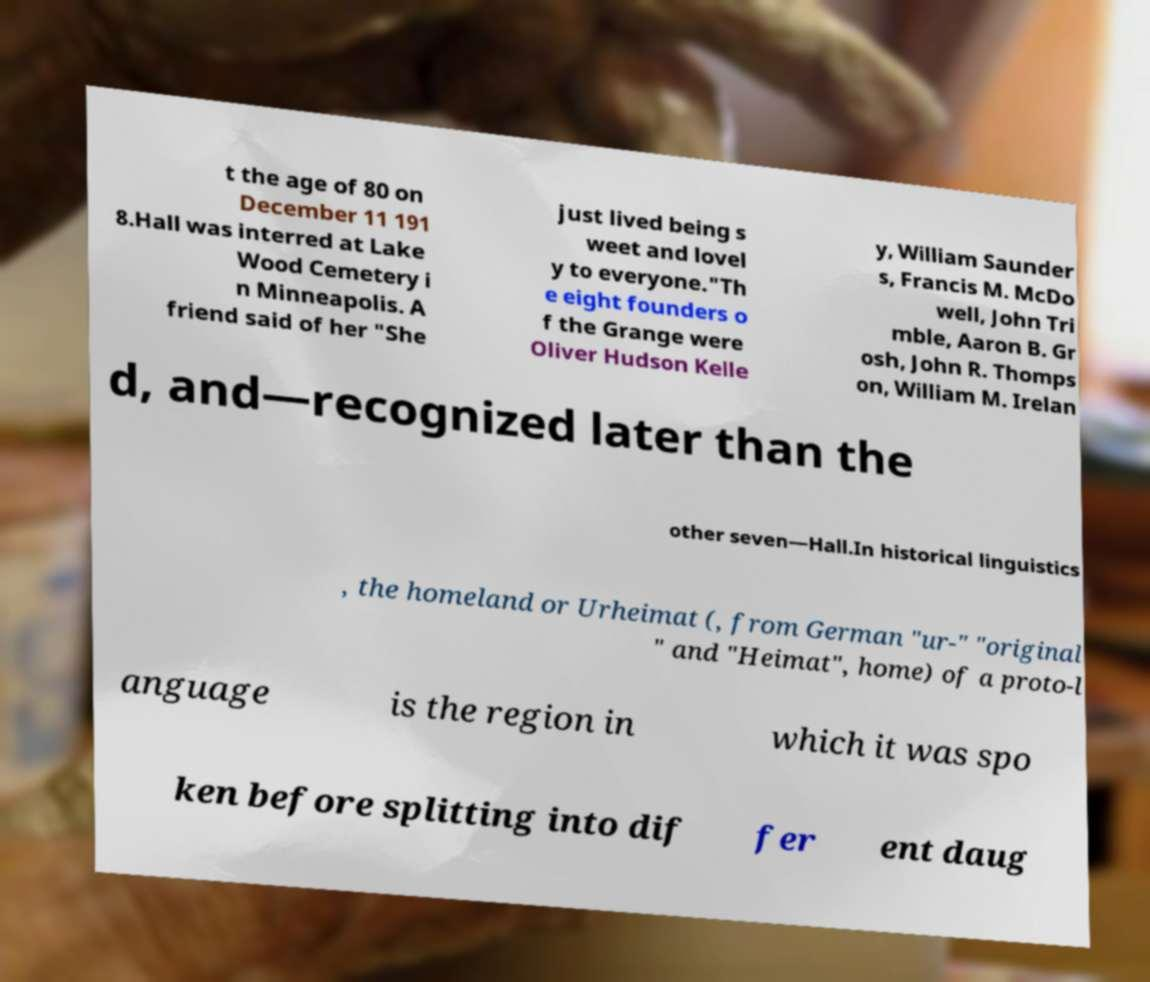Please identify and transcribe the text found in this image. t the age of 80 on December 11 191 8.Hall was interred at Lake Wood Cemetery i n Minneapolis. A friend said of her "She just lived being s weet and lovel y to everyone."Th e eight founders o f the Grange were Oliver Hudson Kelle y, William Saunder s, Francis M. McDo well, John Tri mble, Aaron B. Gr osh, John R. Thomps on, William M. Irelan d, and—recognized later than the other seven—Hall.In historical linguistics , the homeland or Urheimat (, from German "ur-" "original " and "Heimat", home) of a proto-l anguage is the region in which it was spo ken before splitting into dif fer ent daug 